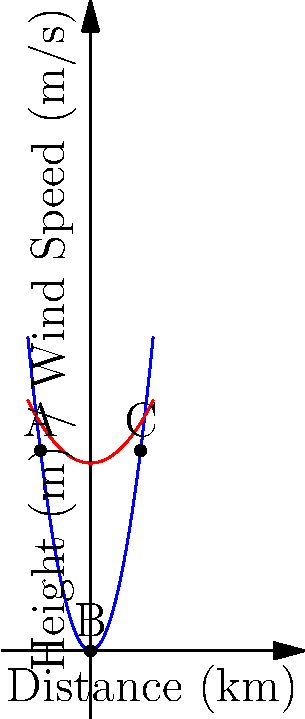Consider the topography and wind speed profile shown in the graph. Points A, B, and C represent potential wind turbine locations at different elevations. Given that wind power is proportional to the cube of wind speed, at which point would a wind turbine likely generate the most power? To determine which point would likely generate the most wind power, we need to consider both the wind speed and the elevation at each point:

1. Wind speed (blue curve):
   A: Lowest wind speed
   B: Medium wind speed
   C: Highest wind speed

2. Elevation (red curve):
   A: Low elevation
   B: Medium elevation
   C: High elevation

3. Wind power calculation:
   Wind power is proportional to the cube of wind speed: $P \propto v^3$

4. Analysis:
   - Point A: Low wind speed and low elevation
   - Point B: Medium wind speed and medium elevation
   - Point C: Highest wind speed and highest elevation

5. Conclusion:
   Point C has both the highest wind speed and the highest elevation. Since wind power is proportional to the cube of wind speed, even a small increase in wind speed results in a significant increase in power output. Additionally, higher elevations generally have less obstruction and more consistent wind patterns.

Therefore, a wind turbine at Point C would likely generate the most power.
Answer: Point C 